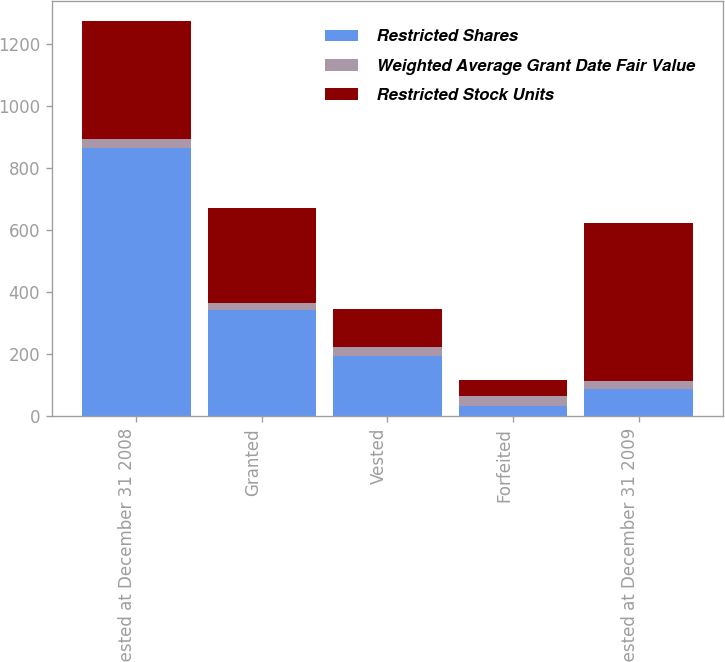Convert chart. <chart><loc_0><loc_0><loc_500><loc_500><stacked_bar_chart><ecel><fcel>Unvested at December 31 2008<fcel>Granted<fcel>Vested<fcel>Forfeited<fcel>Unvested at December 31 2009<nl><fcel>Restricted Shares<fcel>864<fcel>342<fcel>194<fcel>32<fcel>88<nl><fcel>Weighted Average Grant Date Fair Value<fcel>31.59<fcel>23.72<fcel>29.31<fcel>32.96<fcel>26.52<nl><fcel>Restricted Stock Units<fcel>380<fcel>305<fcel>123<fcel>53<fcel>509<nl></chart> 